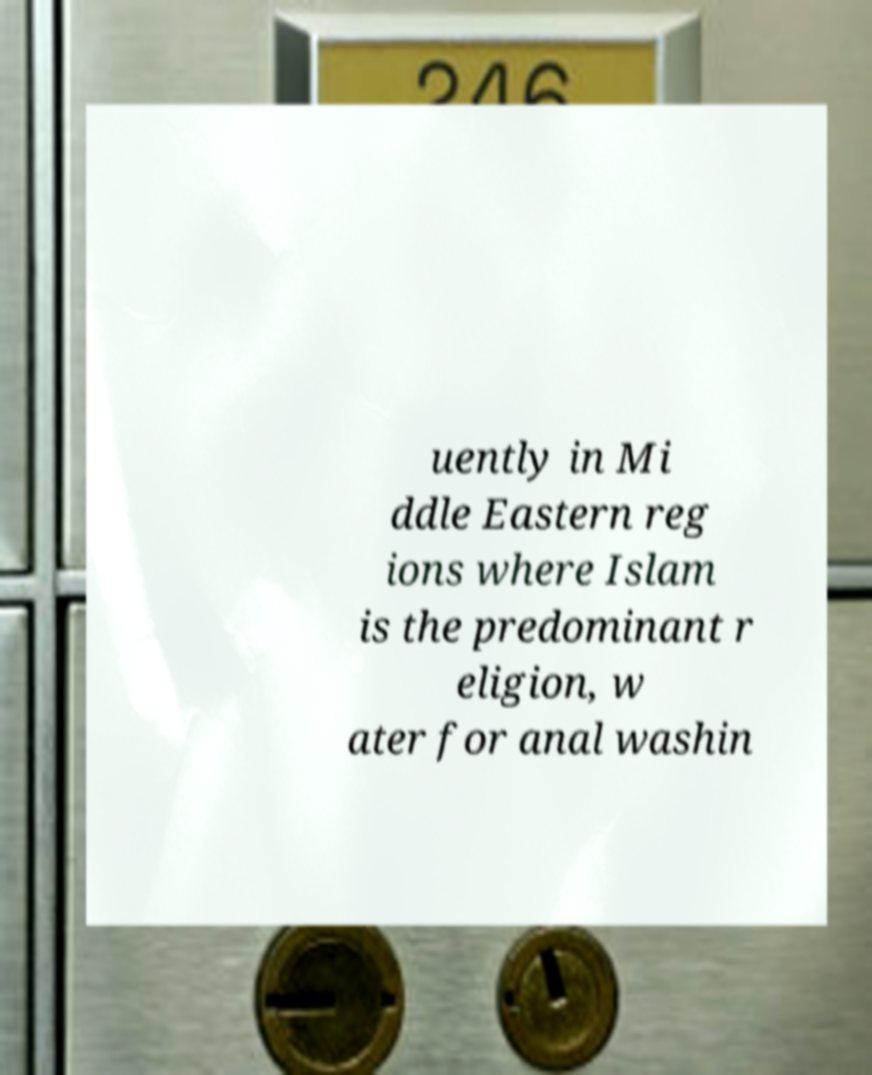Can you read and provide the text displayed in the image?This photo seems to have some interesting text. Can you extract and type it out for me? uently in Mi ddle Eastern reg ions where Islam is the predominant r eligion, w ater for anal washin 